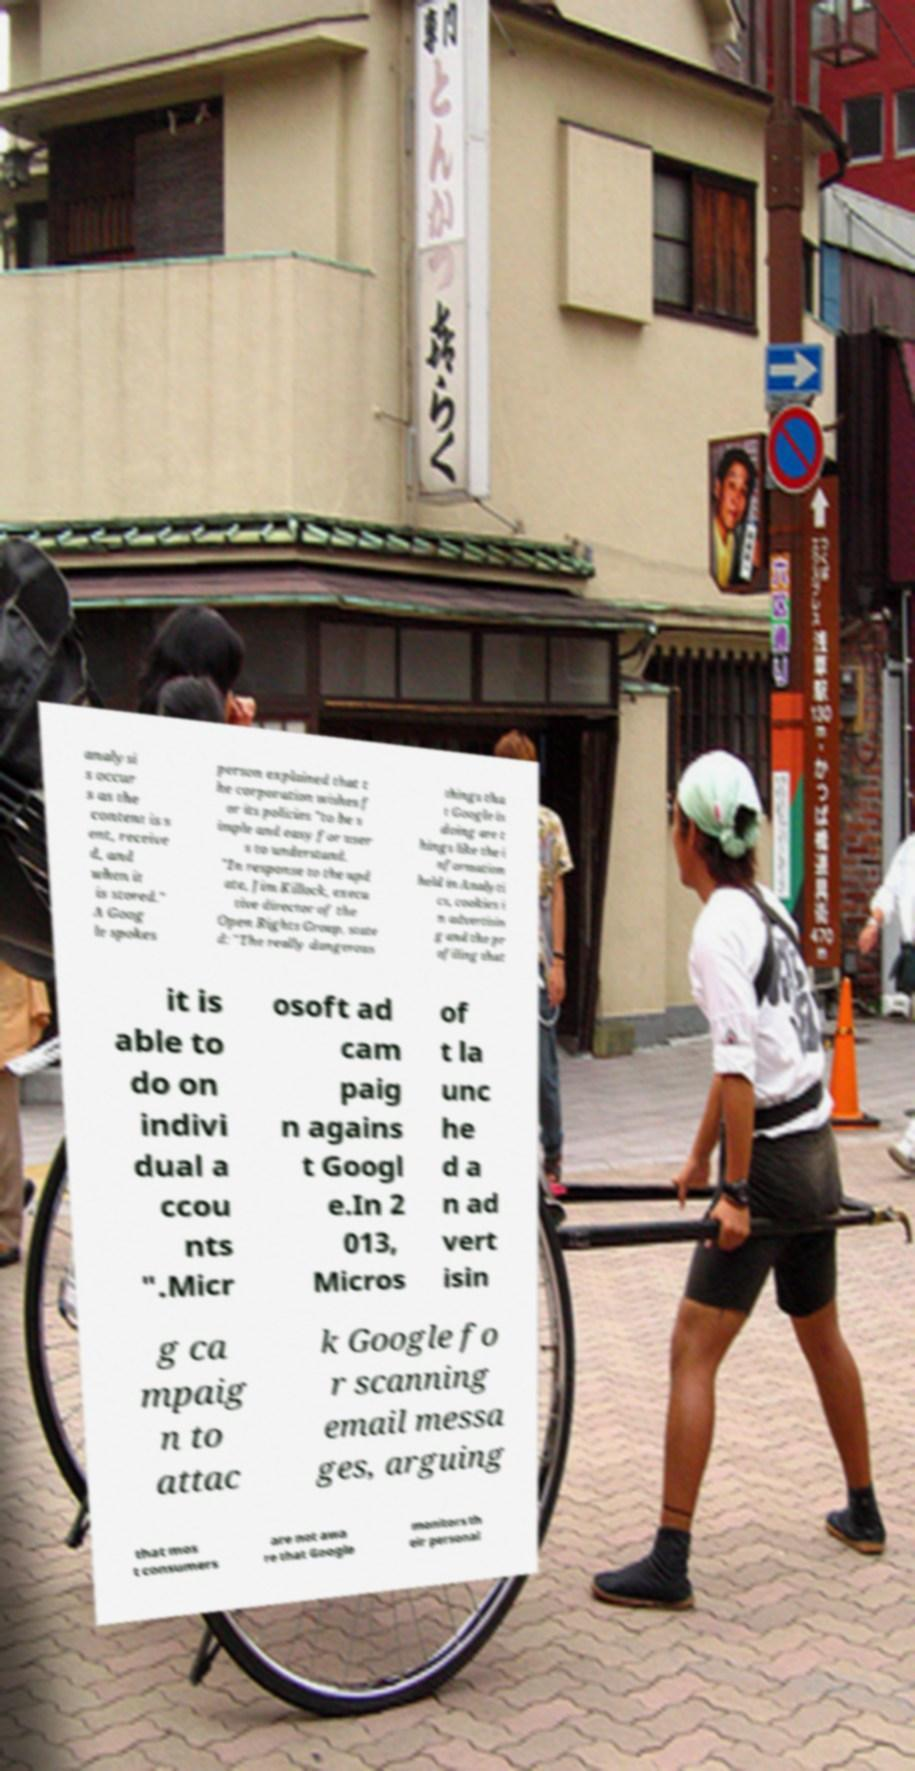I need the written content from this picture converted into text. Can you do that? analysi s occur s as the content is s ent, receive d, and when it is stored." A Goog le spokes person explained that t he corporation wishes f or its policies "to be s imple and easy for user s to understand. "In response to the upd ate, Jim Killock, execu tive director of the Open Rights Group, state d: "The really dangerous things tha t Google is doing are t hings like the i nformation held in Analyti cs, cookies i n advertisin g and the pr ofiling that it is able to do on indivi dual a ccou nts ".Micr osoft ad cam paig n agains t Googl e.In 2 013, Micros of t la unc he d a n ad vert isin g ca mpaig n to attac k Google fo r scanning email messa ges, arguing that mos t consumers are not awa re that Google monitors th eir personal 